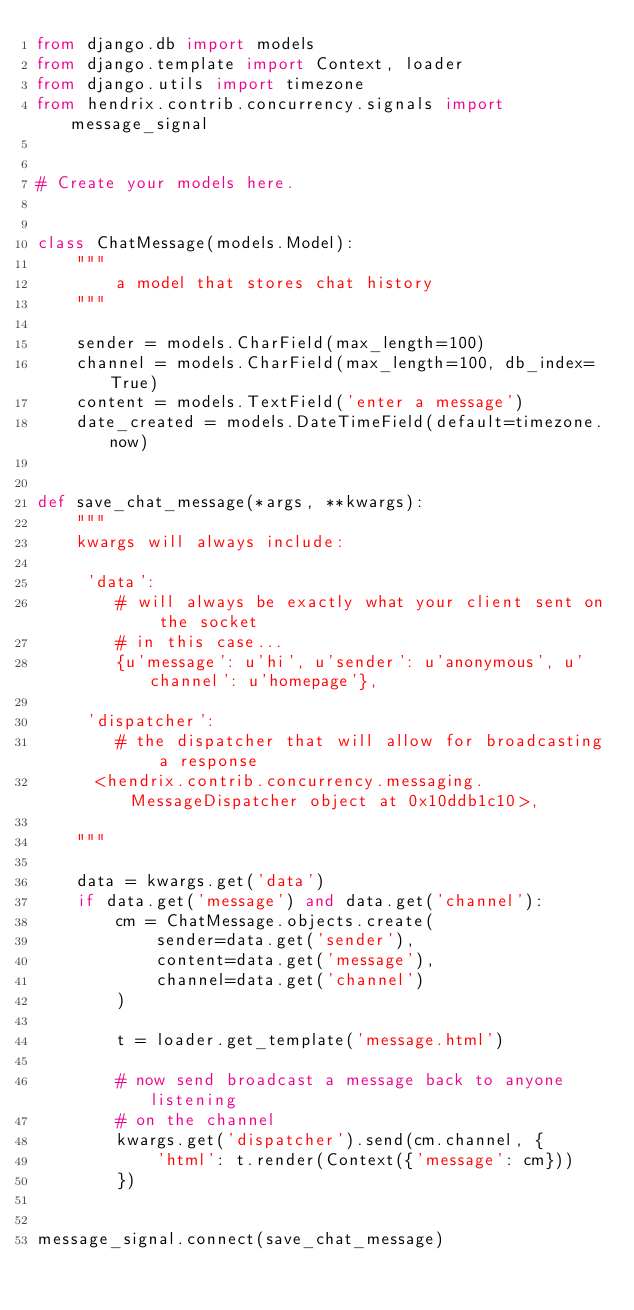<code> <loc_0><loc_0><loc_500><loc_500><_Python_>from django.db import models
from django.template import Context, loader
from django.utils import timezone
from hendrix.contrib.concurrency.signals import message_signal


# Create your models here.


class ChatMessage(models.Model):
    """
        a model that stores chat history
    """

    sender = models.CharField(max_length=100)
    channel = models.CharField(max_length=100, db_index=True)
    content = models.TextField('enter a message')
    date_created = models.DateTimeField(default=timezone.now)


def save_chat_message(*args, **kwargs):
    """
    kwargs will always include:
    
     'data': 
        # will always be exactly what your client sent on the socket
        # in this case...
        {u'message': u'hi', u'sender': u'anonymous', u'channel': u'homepage'},
     
     'dispatcher': 
        # the dispatcher that will allow for broadcasting a response
      <hendrix.contrib.concurrency.messaging.MessageDispatcher object at 0x10ddb1c10>,
    
    """

    data = kwargs.get('data')
    if data.get('message') and data.get('channel'):
        cm = ChatMessage.objects.create(
            sender=data.get('sender'),
            content=data.get('message'),
            channel=data.get('channel')
        )

        t = loader.get_template('message.html')

        # now send broadcast a message back to anyone listening
        # on the channel
        kwargs.get('dispatcher').send(cm.channel, {
            'html': t.render(Context({'message': cm}))
        })


message_signal.connect(save_chat_message)
</code> 